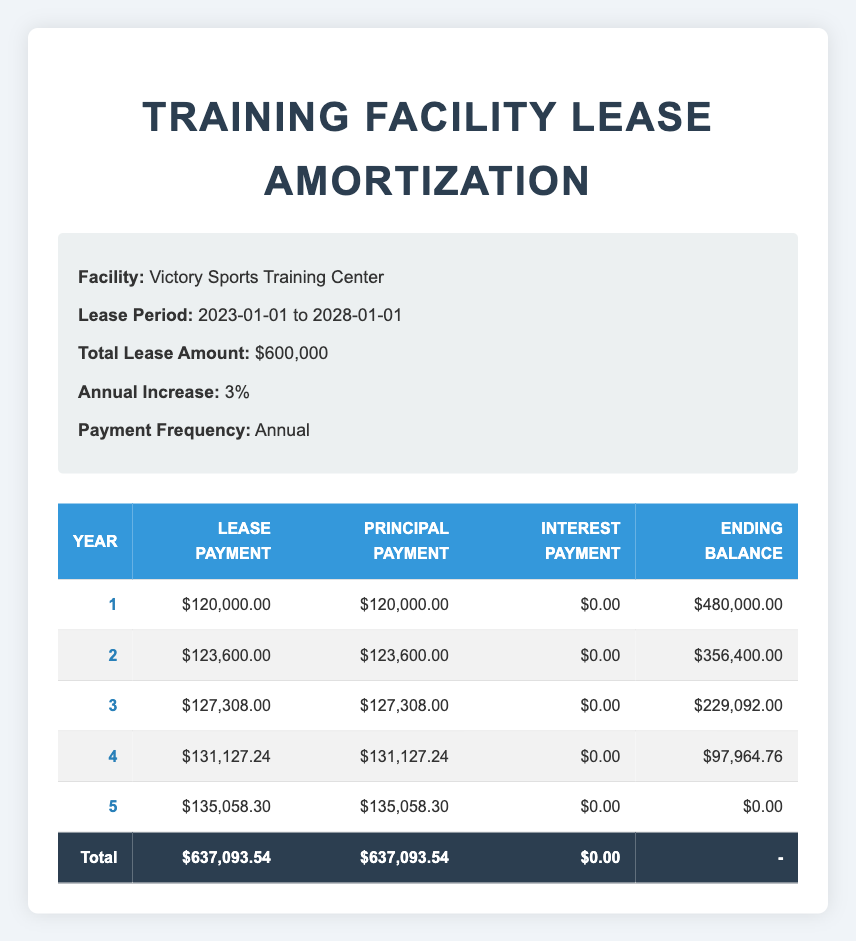What is the total lease payment over the 5 years? To find the total lease payment, we add up all the lease payment amounts for each year. The amounts are: $120,000 (Year 1) + $123,600 (Year 2) + $127,308 (Year 3) + $131,127.24 (Year 4) + $135,058.30 (Year 5) = $637,093.54.
Answer: $637,093.54 How much is the principal payment in Year 4? The principal payment for Year 4 is clearly stated in the table as $131,127.24.
Answer: $131,127.24 Is there any interest payment for the entire duration of the lease? Checking the interest payment column for all years shows $0.00 for each year, meaning there are no interest payments through the lease term.
Answer: Yes What is the ending balance at the end of Year 2? The ending balance for Year 2, as stated in the table, is $356,400.
Answer: $356,400 Which year has the highest lease payment? Looking through the lease payment values for each year, Year 5 has the highest lease payment of $135,058.30.
Answer: Year 5 Calculate the average lease payment across all five years. To find the average, sum the lease payments: $120,000 + $123,600 + $127,308 + $131,127.24 + $135,058.30 = $637,093.54. Then divide by the number of years (5): $637,093.54 / 5 = $127,418.71.
Answer: $127,418.71 What is the difference in ending balance between Year 1 and Year 5? The ending balance in Year 1 is $480,000 and in Year 5 it is $0. To find the difference, subtract Year 5 balance from Year 1: $480,000 - $0 = $480,000.
Answer: $480,000 Is the lease payment in Year 3 more than the lease payment in Year 2? Comparing Year 3 lease payment of $127,308 with Year 2 lease payment of $123,600 shows that Year 3 is greater, thus the answer is yes.
Answer: Yes 